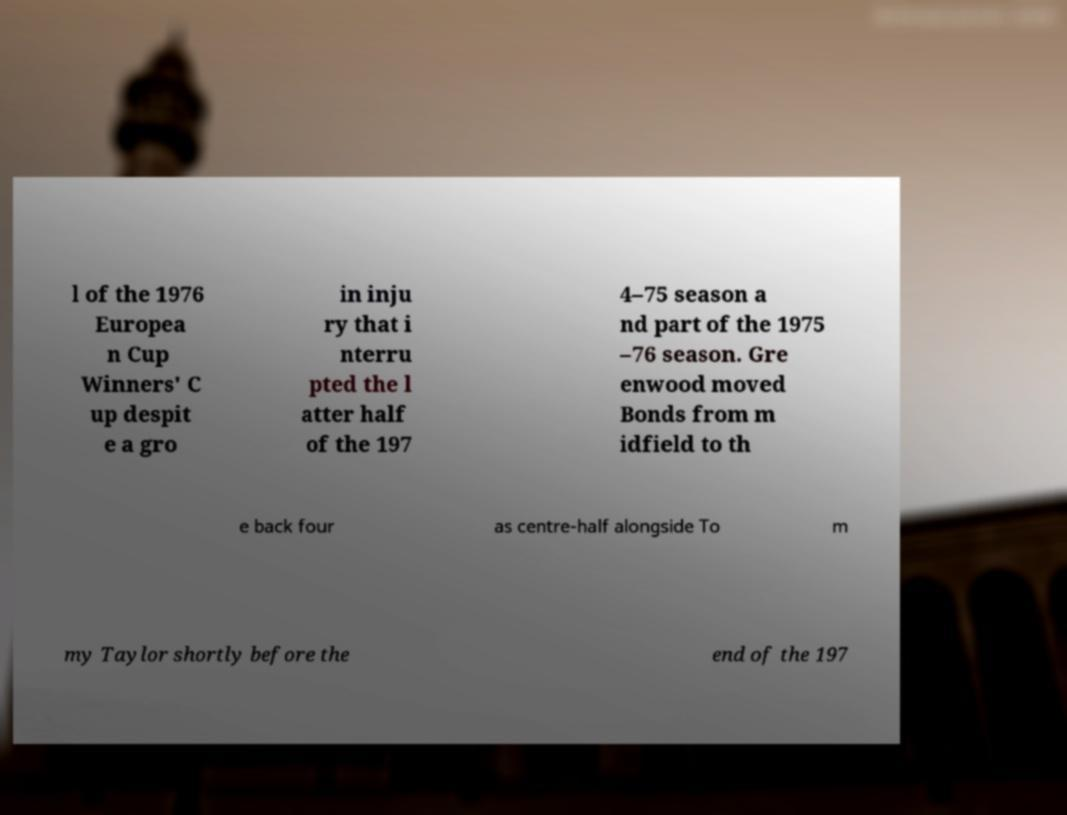I need the written content from this picture converted into text. Can you do that? l of the 1976 Europea n Cup Winners' C up despit e a gro in inju ry that i nterru pted the l atter half of the 197 4–75 season a nd part of the 1975 –76 season. Gre enwood moved Bonds from m idfield to th e back four as centre-half alongside To m my Taylor shortly before the end of the 197 